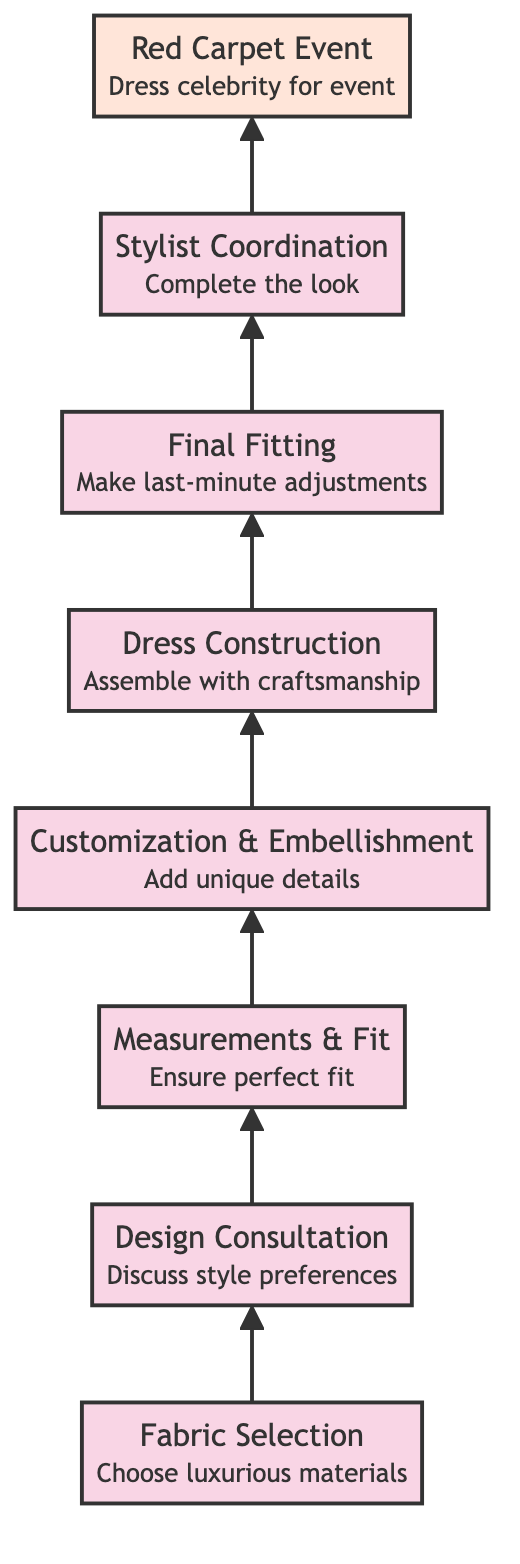What is the first step in the process? The first step in the diagram is the node labeled "Fabric Selection," which appears at the bottom of the flow chart, indicating it is the initial action in customizing a gown.
Answer: Fabric Selection How many steps are there in total? The diagram features a total of eight distinct steps, from "Fabric Selection" at the base to "Red Carpet Event" at the top.
Answer: Eight What is the last step before the red carpet event? The final step before the red carpet event is "Stylist Coordination," which immediately precedes the final event in the upward flow of the diagram.
Answer: Stylist Coordination Which step involves taking measurements? The step involving taking measurements is "Measurements & Fit." This is clearly indicated in the sequence leading toward the red carpet event.
Answer: Measurements & Fit What is added during the "Customization & Embellishment" step? During the "Customization & Embellishment" step, unique details like beading, sequins, or embroidery are added to the gown, as highlighted in the diagram's description of this step.
Answer: Unique details What’s the relationship between "Design Consultation" and "Dress Construction"? The relationship is that "Design Consultation" leads to "Dress Construction," as indicated by the arrow connecting these two nodes. "Design Consultation" informs the design, which is then constructed in the following step.
Answer: Design Consultation leads to Dress Construction What comes immediately after "Final Fitting"? The step that comes immediately after "Final Fitting" is "Stylist Coordination," which shows that adjustments and styling are performed before the final event.
Answer: Stylist Coordination How does the process flow in this diagram? The process flows upwards from "Fabric Selection" at the bottom of the diagram, progressing through each step to culminate in the "Red Carpet Event" at the top, indicating a sequential build-up to the event.
Answer: Bottom to top 